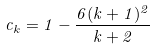Convert formula to latex. <formula><loc_0><loc_0><loc_500><loc_500>c _ { k } = 1 - \frac { 6 ( k + 1 ) ^ { 2 } } { k + 2 }</formula> 